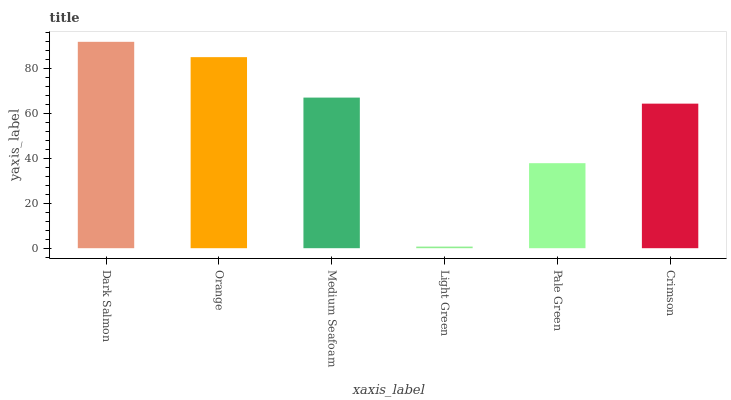Is Light Green the minimum?
Answer yes or no. Yes. Is Dark Salmon the maximum?
Answer yes or no. Yes. Is Orange the minimum?
Answer yes or no. No. Is Orange the maximum?
Answer yes or no. No. Is Dark Salmon greater than Orange?
Answer yes or no. Yes. Is Orange less than Dark Salmon?
Answer yes or no. Yes. Is Orange greater than Dark Salmon?
Answer yes or no. No. Is Dark Salmon less than Orange?
Answer yes or no. No. Is Medium Seafoam the high median?
Answer yes or no. Yes. Is Crimson the low median?
Answer yes or no. Yes. Is Pale Green the high median?
Answer yes or no. No. Is Medium Seafoam the low median?
Answer yes or no. No. 